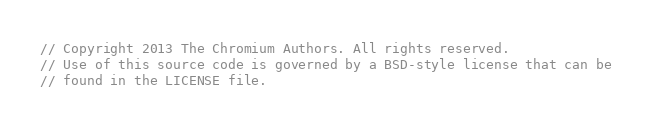Convert code to text. <code><loc_0><loc_0><loc_500><loc_500><_ObjectiveC_>// Copyright 2013 The Chromium Authors. All rights reserved.
// Use of this source code is governed by a BSD-style license that can be
// found in the LICENSE file.
</code> 